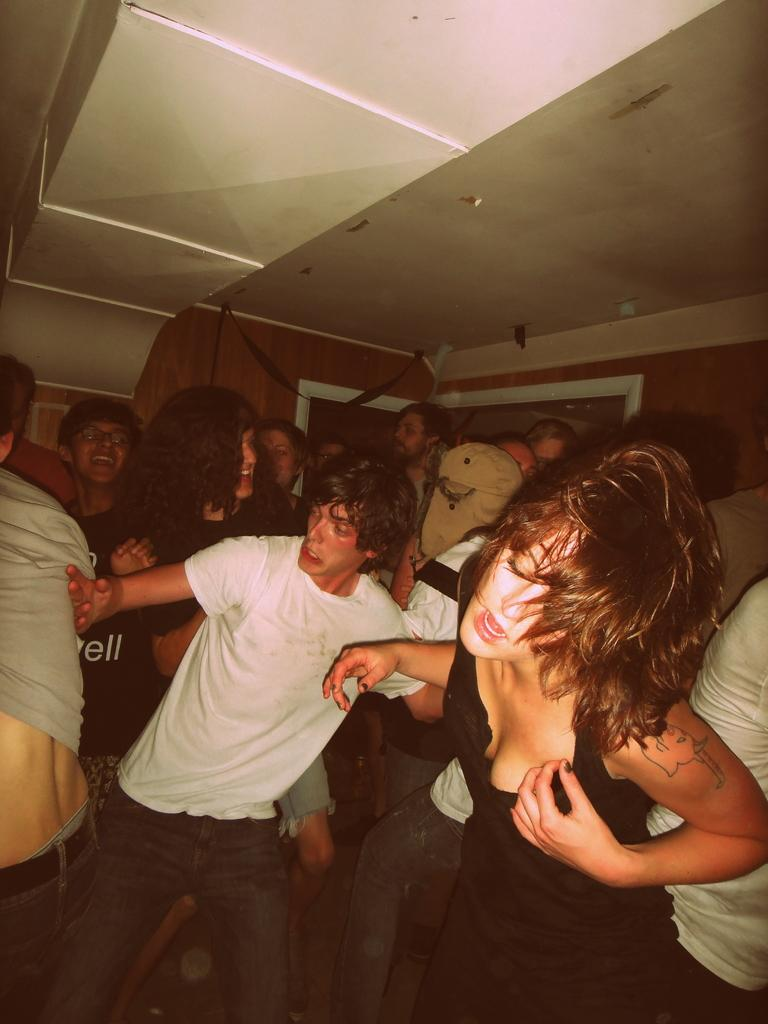What are the people in the image doing? The men and women in the image are dancing. What type of structure can be seen in the background of the image? There is a wooden wall and a wooden ceiling in the background of the image. What type of boundary is present between the dancers and the wooden wall in the image? There is no boundary mentioned or visible between the dancers and the wooden wall in the image. Can you see a car parked near the wooden wall in the image? There is no car present in the image; it features men and women dancing with a wooden wall and ceiling in the background. 